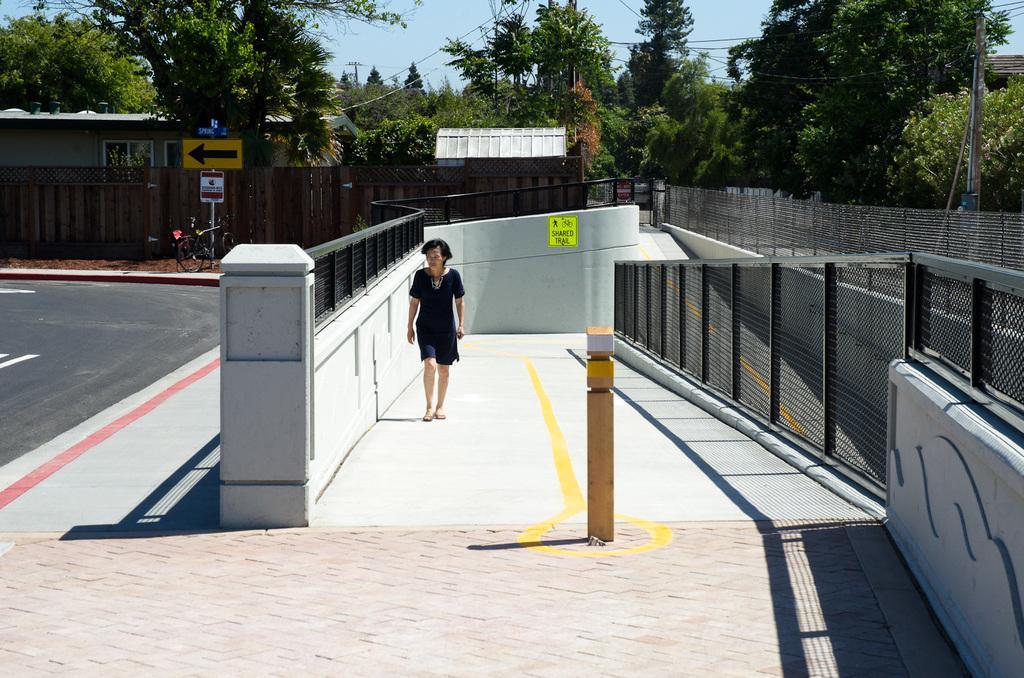Please provide a concise description of this image. In the foreground I can see fence, boards, bicycle and a person is walking on the road. In the background I can see trees, buildings, light poles, wires, windows and the sky. This image is taken may be during a day. 